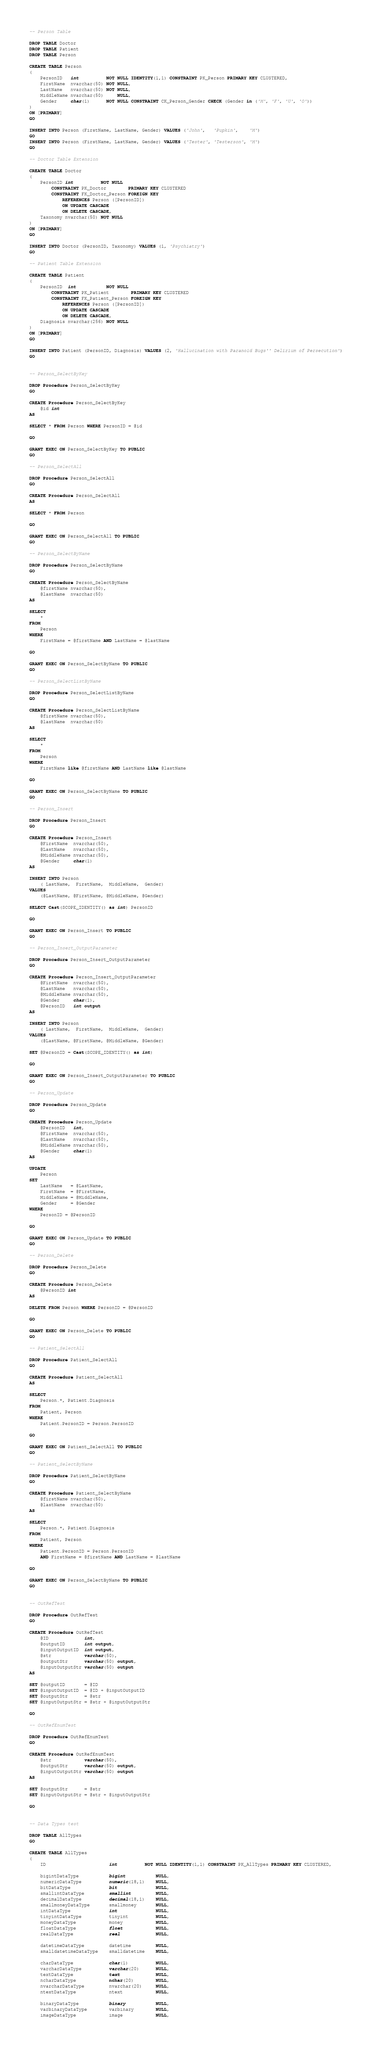Convert code to text. <code><loc_0><loc_0><loc_500><loc_500><_SQL_>-- Person Table

DROP TABLE Doctor
DROP TABLE Patient
DROP TABLE Person

CREATE TABLE Person
(
	PersonID   int          NOT NULL IDENTITY(1,1) CONSTRAINT PK_Person PRIMARY KEY CLUSTERED,
	FirstName  nvarchar(50) NOT NULL,
	LastName   nvarchar(50) NOT NULL,
	MiddleName nvarchar(50)     NULL,
	Gender     char(1)      NOT NULL CONSTRAINT CK_Person_Gender CHECK (Gender in ('M', 'F', 'U', 'O'))
)
ON [PRIMARY]
GO

INSERT INTO Person (FirstName, LastName, Gender) VALUES ('John',   'Pupkin',    'M')
GO
INSERT INTO Person (FirstName, LastName, Gender) VALUES ('Tester', 'Testerson', 'M')
GO

-- Doctor Table Extension

CREATE TABLE Doctor
(
	PersonID int          NOT NULL
		CONSTRAINT PK_Doctor        PRIMARY KEY CLUSTERED
		CONSTRAINT FK_Doctor_Person FOREIGN KEY
			REFERENCES Person ([PersonID])
			ON UPDATE CASCADE
			ON DELETE CASCADE,
	Taxonomy nvarchar(50) NOT NULL
)
ON [PRIMARY]
GO

INSERT INTO Doctor (PersonID, Taxonomy) VALUES (1, 'Psychiatry')
GO

-- Patient Table Extension

CREATE TABLE Patient
(
	PersonID  int           NOT NULL
		CONSTRAINT PK_Patient        PRIMARY KEY CLUSTERED
		CONSTRAINT FK_Patient_Person FOREIGN KEY
			REFERENCES Person ([PersonID])
			ON UPDATE CASCADE
			ON DELETE CASCADE,
	Diagnosis nvarchar(256) NOT NULL
)
ON [PRIMARY]
GO

INSERT INTO Patient (PersonID, Diagnosis) VALUES (2, 'Hallucination with Paranoid Bugs'' Delirium of Persecution')
GO


-- Person_SelectByKey

DROP Procedure Person_SelectByKey
GO

CREATE Procedure Person_SelectByKey
	@id int
AS

SELECT * FROM Person WHERE PersonID = @id

GO

GRANT EXEC ON Person_SelectByKey TO PUBLIC
GO

-- Person_SelectAll

DROP Procedure Person_SelectAll
GO

CREATE Procedure Person_SelectAll
AS

SELECT * FROM Person

GO

GRANT EXEC ON Person_SelectAll TO PUBLIC
GO

-- Person_SelectByName

DROP Procedure Person_SelectByName
GO

CREATE Procedure Person_SelectByName
	@firstName nvarchar(50),
	@lastName  nvarchar(50)
AS

SELECT
	*
FROM
	Person
WHERE
	FirstName = @firstName AND LastName = @lastName

GO

GRANT EXEC ON Person_SelectByName TO PUBLIC
GO

-- Person_SelectListByName

DROP Procedure Person_SelectListByName
GO

CREATE Procedure Person_SelectListByName
	@firstName nvarchar(50),
	@lastName  nvarchar(50)
AS

SELECT
	*
FROM
	Person
WHERE
	FirstName like @firstName AND LastName like @lastName

GO

GRANT EXEC ON Person_SelectByName TO PUBLIC
GO

-- Person_Insert

DROP Procedure Person_Insert
GO

CREATE Procedure Person_Insert
	@FirstName  nvarchar(50),
	@LastName   nvarchar(50),
	@MiddleName nvarchar(50),
	@Gender     char(1)
AS

INSERT INTO Person
	( LastName,  FirstName,  MiddleName,  Gender)
VALUES
	(@LastName, @FirstName, @MiddleName, @Gender)

SELECT Cast(SCOPE_IDENTITY() as int) PersonID

GO

GRANT EXEC ON Person_Insert TO PUBLIC
GO

-- Person_Insert_OutputParameter

DROP Procedure Person_Insert_OutputParameter
GO

CREATE Procedure Person_Insert_OutputParameter
	@FirstName  nvarchar(50),
	@LastName   nvarchar(50),
	@MiddleName nvarchar(50),
	@Gender     char(1),
	@PersonID   int output
AS

INSERT INTO Person
	( LastName,  FirstName,  MiddleName,  Gender)
VALUES
	(@LastName, @FirstName, @MiddleName, @Gender)

SET @PersonID = Cast(SCOPE_IDENTITY() as int)

GO

GRANT EXEC ON Person_Insert_OutputParameter TO PUBLIC
GO

-- Person_Update

DROP Procedure Person_Update
GO

CREATE Procedure Person_Update
	@PersonID   int,
	@FirstName  nvarchar(50),
	@LastName   nvarchar(50),
	@MiddleName nvarchar(50),
	@Gender     char(1)
AS

UPDATE
	Person
SET
	LastName   = @LastName,
	FirstName  = @FirstName,
	MiddleName = @MiddleName,
	Gender     = @Gender
WHERE
	PersonID = @PersonID

GO

GRANT EXEC ON Person_Update TO PUBLIC
GO

-- Person_Delete

DROP Procedure Person_Delete
GO

CREATE Procedure Person_Delete
	@PersonID int
AS

DELETE FROM Person WHERE PersonID = @PersonID

GO

GRANT EXEC ON Person_Delete TO PUBLIC
GO

-- Patient_SelectAll

DROP Procedure Patient_SelectAll
GO

CREATE Procedure Patient_SelectAll
AS

SELECT
	Person.*, Patient.Diagnosis
FROM
	Patient, Person
WHERE
	Patient.PersonID = Person.PersonID

GO

GRANT EXEC ON Patient_SelectAll TO PUBLIC
GO

-- Patient_SelectByName

DROP Procedure Patient_SelectByName
GO

CREATE Procedure Patient_SelectByName
	@firstName nvarchar(50),
	@lastName  nvarchar(50)
AS

SELECT
	Person.*, Patient.Diagnosis
FROM
	Patient, Person
WHERE
	Patient.PersonID = Person.PersonID
	AND FirstName = @firstName AND LastName = @lastName

GO

GRANT EXEC ON Person_SelectByName TO PUBLIC
GO


-- OutRefTest

DROP Procedure OutRefTest
GO

CREATE Procedure OutRefTest
	@ID             int,
	@outputID       int output,
	@inputOutputID  int output,
	@str            varchar(50),
	@outputStr      varchar(50) output,
	@inputOutputStr varchar(50) output
AS

SET @outputID       = @ID
SET @inputOutputID  = @ID + @inputOutputID
SET @outputStr      = @str
SET @inputOutputStr = @str + @inputOutputStr

GO

-- OutRefEnumTest

DROP Procedure OutRefEnumTest
GO

CREATE Procedure OutRefEnumTest
	@str            varchar(50),
	@outputStr      varchar(50) output,
	@inputOutputStr varchar(50) output
AS

SET @outputStr      = @str
SET @inputOutputStr = @str + @inputOutputStr

GO


-- Data Types test

DROP TABLE AllTypes
GO

CREATE TABLE AllTypes
(
	ID                       int          NOT NULL IDENTITY(1,1) CONSTRAINT PK_AllTypes PRIMARY KEY CLUSTERED,

	bigintDataType           bigint           NULL,
	numericDataType          numeric(18,1)    NULL,
	bitDataType              bit              NULL,
	smallintDataType         smallint         NULL,
	decimalDataType          decimal(18,1)    NULL,
	smallmoneyDataType       smallmoney       NULL,
	intDataType              int              NULL,
	tinyintDataType          tinyint          NULL,
	moneyDataType            money            NULL,
	floatDataType            float            NULL,
	realDataType             real             NULL,

	datetimeDataType         datetime         NULL,
	smalldatetimeDataType    smalldatetime    NULL,

	charDataType             char(1)          NULL,
	varcharDataType          varchar(20)      NULL,
	textDataType             text             NULL,
	ncharDataType            nchar(20)        NULL,
	nvarcharDataType         nvarchar(20)     NULL,
	ntextDataType            ntext            NULL,

	binaryDataType           binary           NULL,
	varbinaryDataType        varbinary        NULL,
	imageDataType            image            NULL,
</code> 